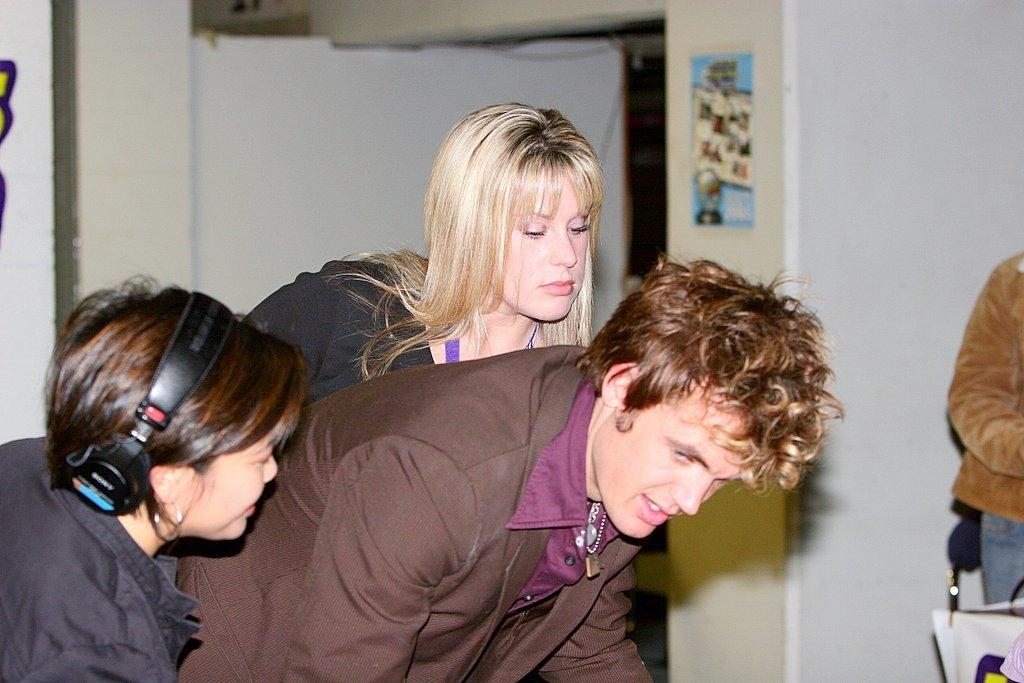How many people are in the image? There are people in the image. Can you describe any specific clothing or accessories worn by the people? One person is wearing a headset. What can be seen in the background of the image? There is a poster on a wall in the background of the image. What type of mouth does the kettle have in the image? There is no kettle present in the image, so it is not possible to determine what type of mouth it might have. 